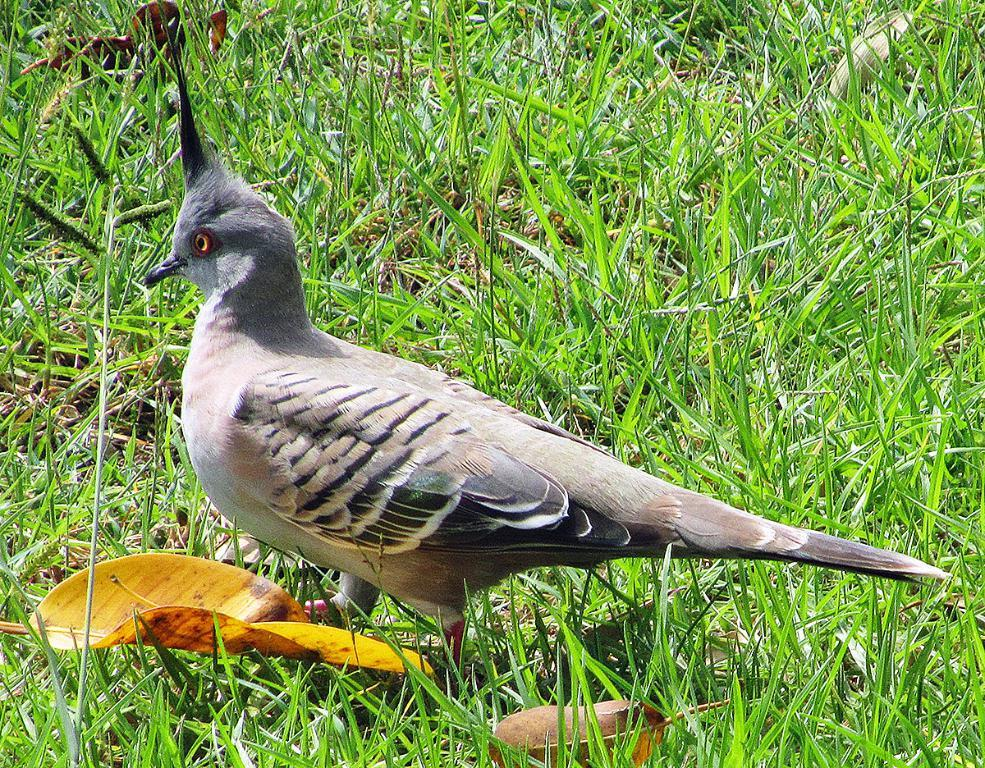Where was the image taken? The image was taken outdoors. What type of surface can be seen in the image? There is a ground with grass in the image. What animal is present on the ground in the image? There is a bird on the ground in the image. What type of plant material is visible in the image? There is a leaf in the image. What type of cup can be seen hanging from the string in the image? There is no cup or string present in the image. 